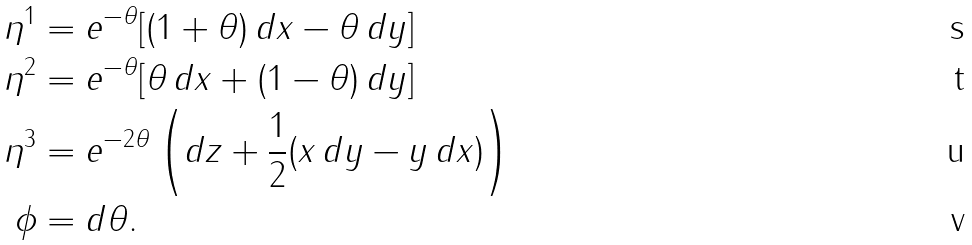<formula> <loc_0><loc_0><loc_500><loc_500>\eta ^ { 1 } & = e ^ { - \theta } [ ( 1 + \theta ) \, d x - \theta \, d y ] \\ \eta ^ { 2 } & = e ^ { - \theta } [ \theta \, d x + ( 1 - \theta ) \, d y ] \\ \eta ^ { 3 } & = e ^ { - 2 \theta } \left ( d z + \frac { 1 } { 2 } ( x \, d y - y \, d x ) \right ) \\ \phi & = d \theta .</formula> 